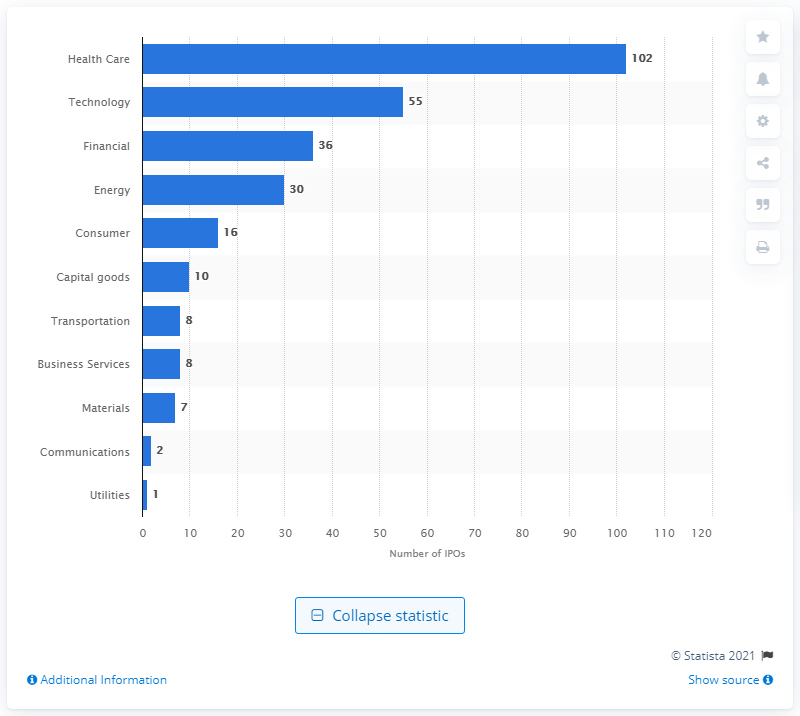Mention a couple of crucial points in this snapshot. In 2014, there were 102 initial public offering (IPO) deals in the health care sector. 